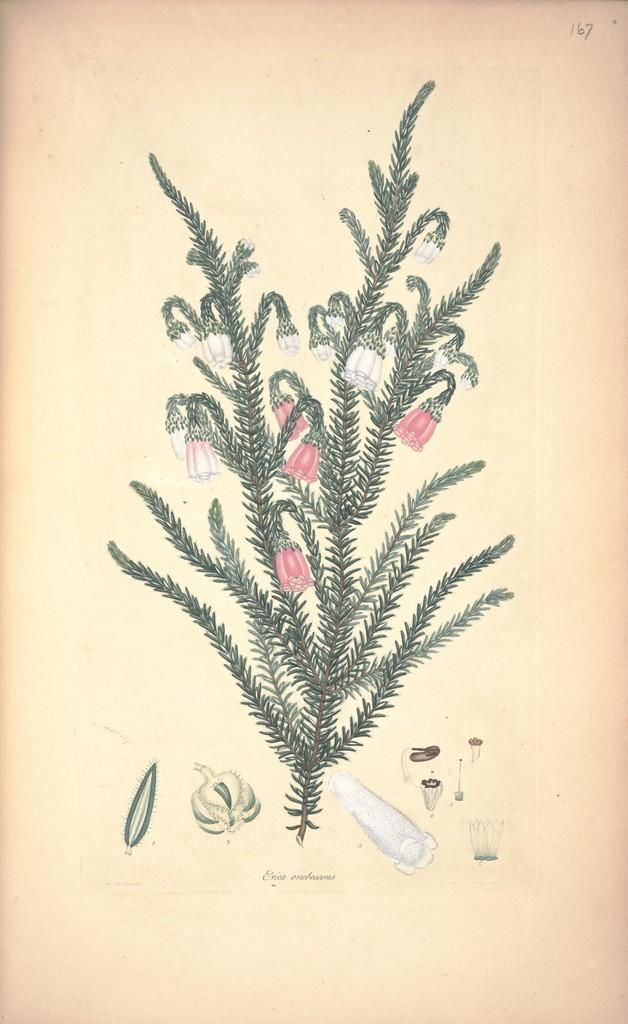What is the main subject of the image? The main subject of the image is a plant poster. Where is the plant poster located in the image? The plant poster is in the center of the image. What type of chain can be seen attached to the parcel in the image? There is no parcel or chain present in the image; it only features a plant poster in the center. 